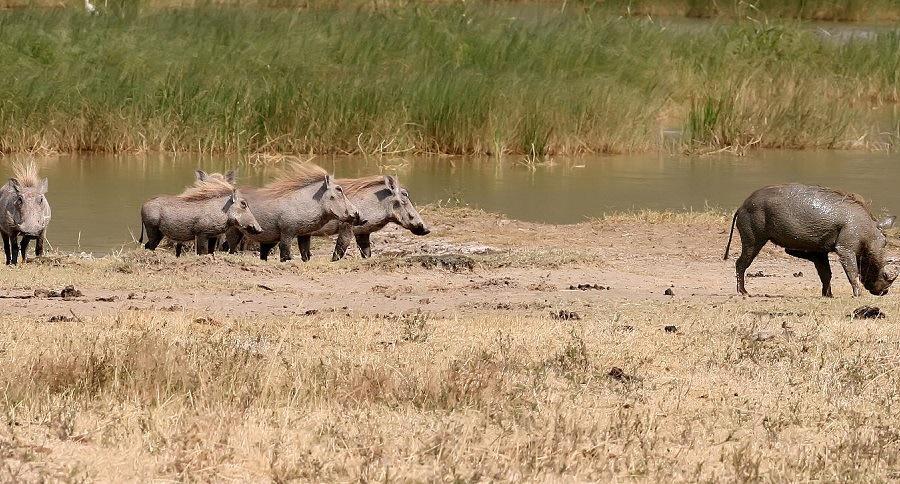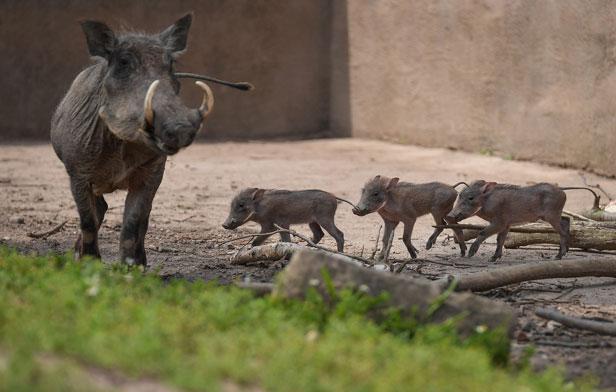The first image is the image on the left, the second image is the image on the right. For the images shown, is this caption "Right image contains one forward facing adult boar and multiple baby boars." true? Answer yes or no. Yes. The first image is the image on the left, the second image is the image on the right. Given the left and right images, does the statement "One of the images contains exactly two baby boars." hold true? Answer yes or no. No. 